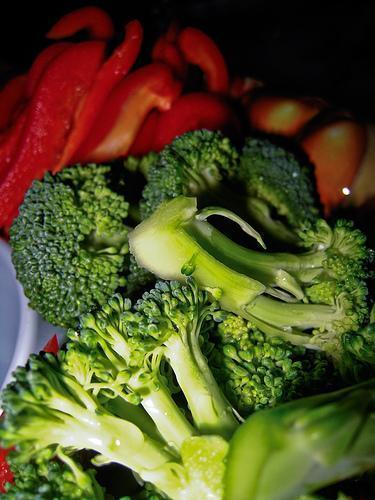How many green vegetables are in the image?
Give a very brief answer. 6. 